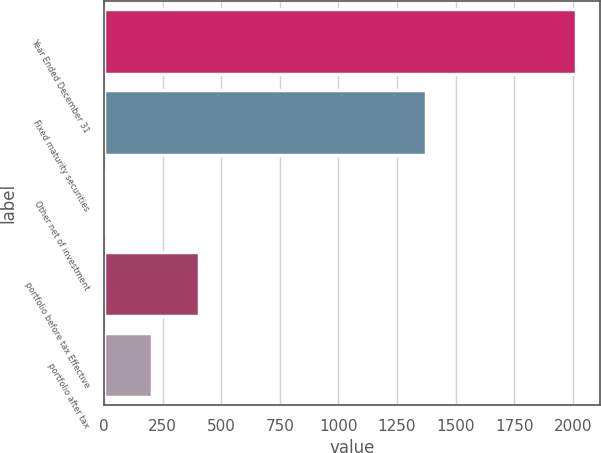Convert chart. <chart><loc_0><loc_0><loc_500><loc_500><bar_chart><fcel>Year Ended December 31<fcel>Fixed maturity securities<fcel>Other net of investment<fcel>portfolio before tax Effective<fcel>portfolio after tax<nl><fcel>2015<fcel>1375<fcel>3<fcel>405.4<fcel>204.2<nl></chart> 